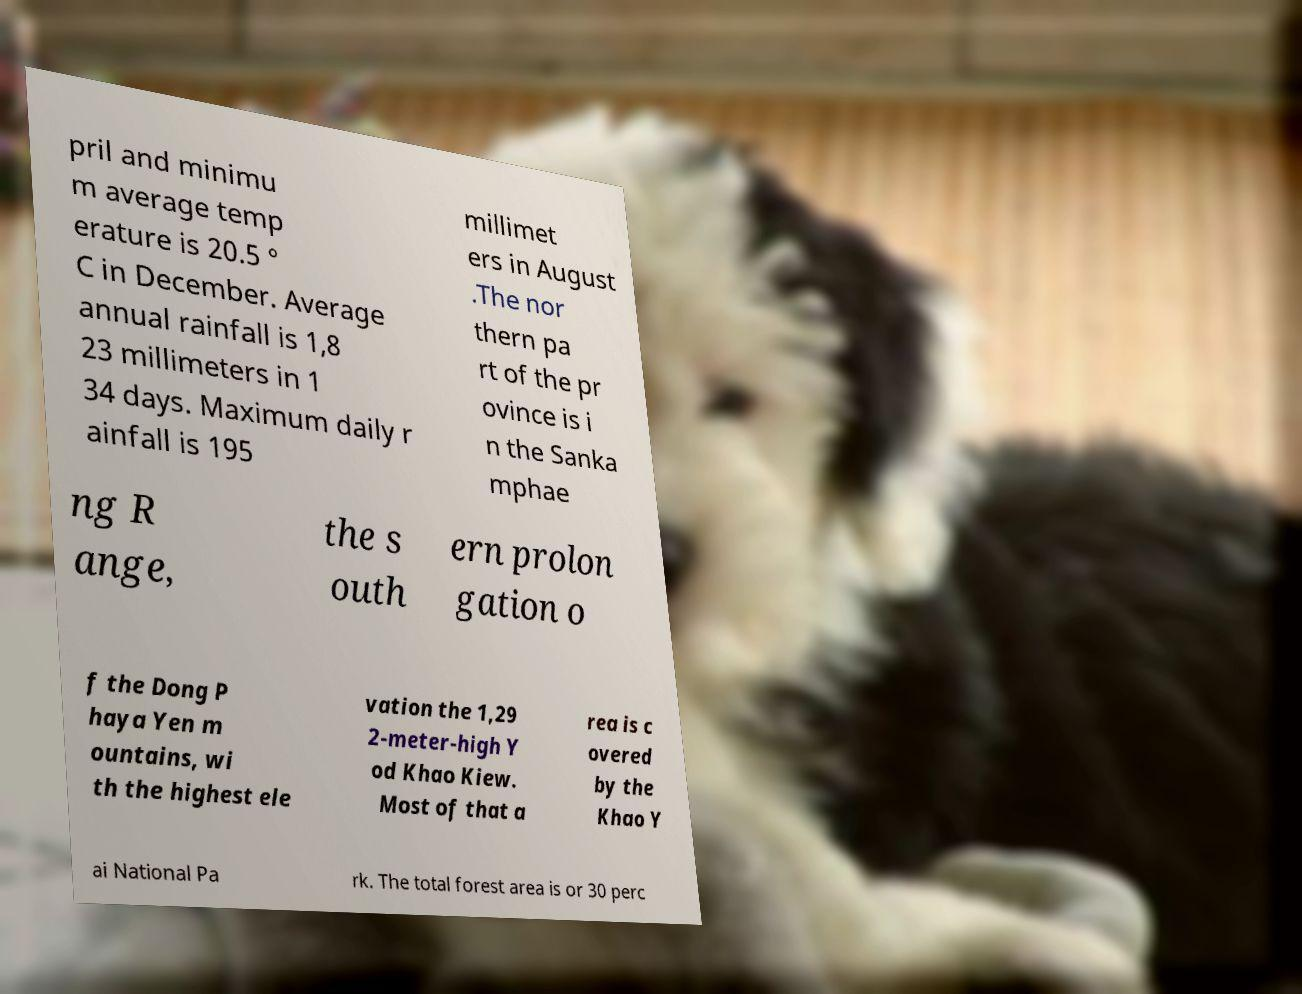I need the written content from this picture converted into text. Can you do that? pril and minimu m average temp erature is 20.5 ° C in December. Average annual rainfall is 1,8 23 millimeters in 1 34 days. Maximum daily r ainfall is 195 millimet ers in August .The nor thern pa rt of the pr ovince is i n the Sanka mphae ng R ange, the s outh ern prolon gation o f the Dong P haya Yen m ountains, wi th the highest ele vation the 1,29 2-meter-high Y od Khao Kiew. Most of that a rea is c overed by the Khao Y ai National Pa rk. The total forest area is or 30 perc 